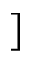<formula> <loc_0><loc_0><loc_500><loc_500>]</formula> 